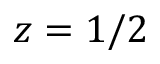<formula> <loc_0><loc_0><loc_500><loc_500>z = 1 / 2</formula> 